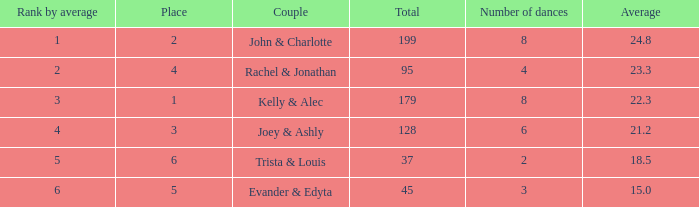What is the highest average that has 6 dances and a total of over 128? None. 